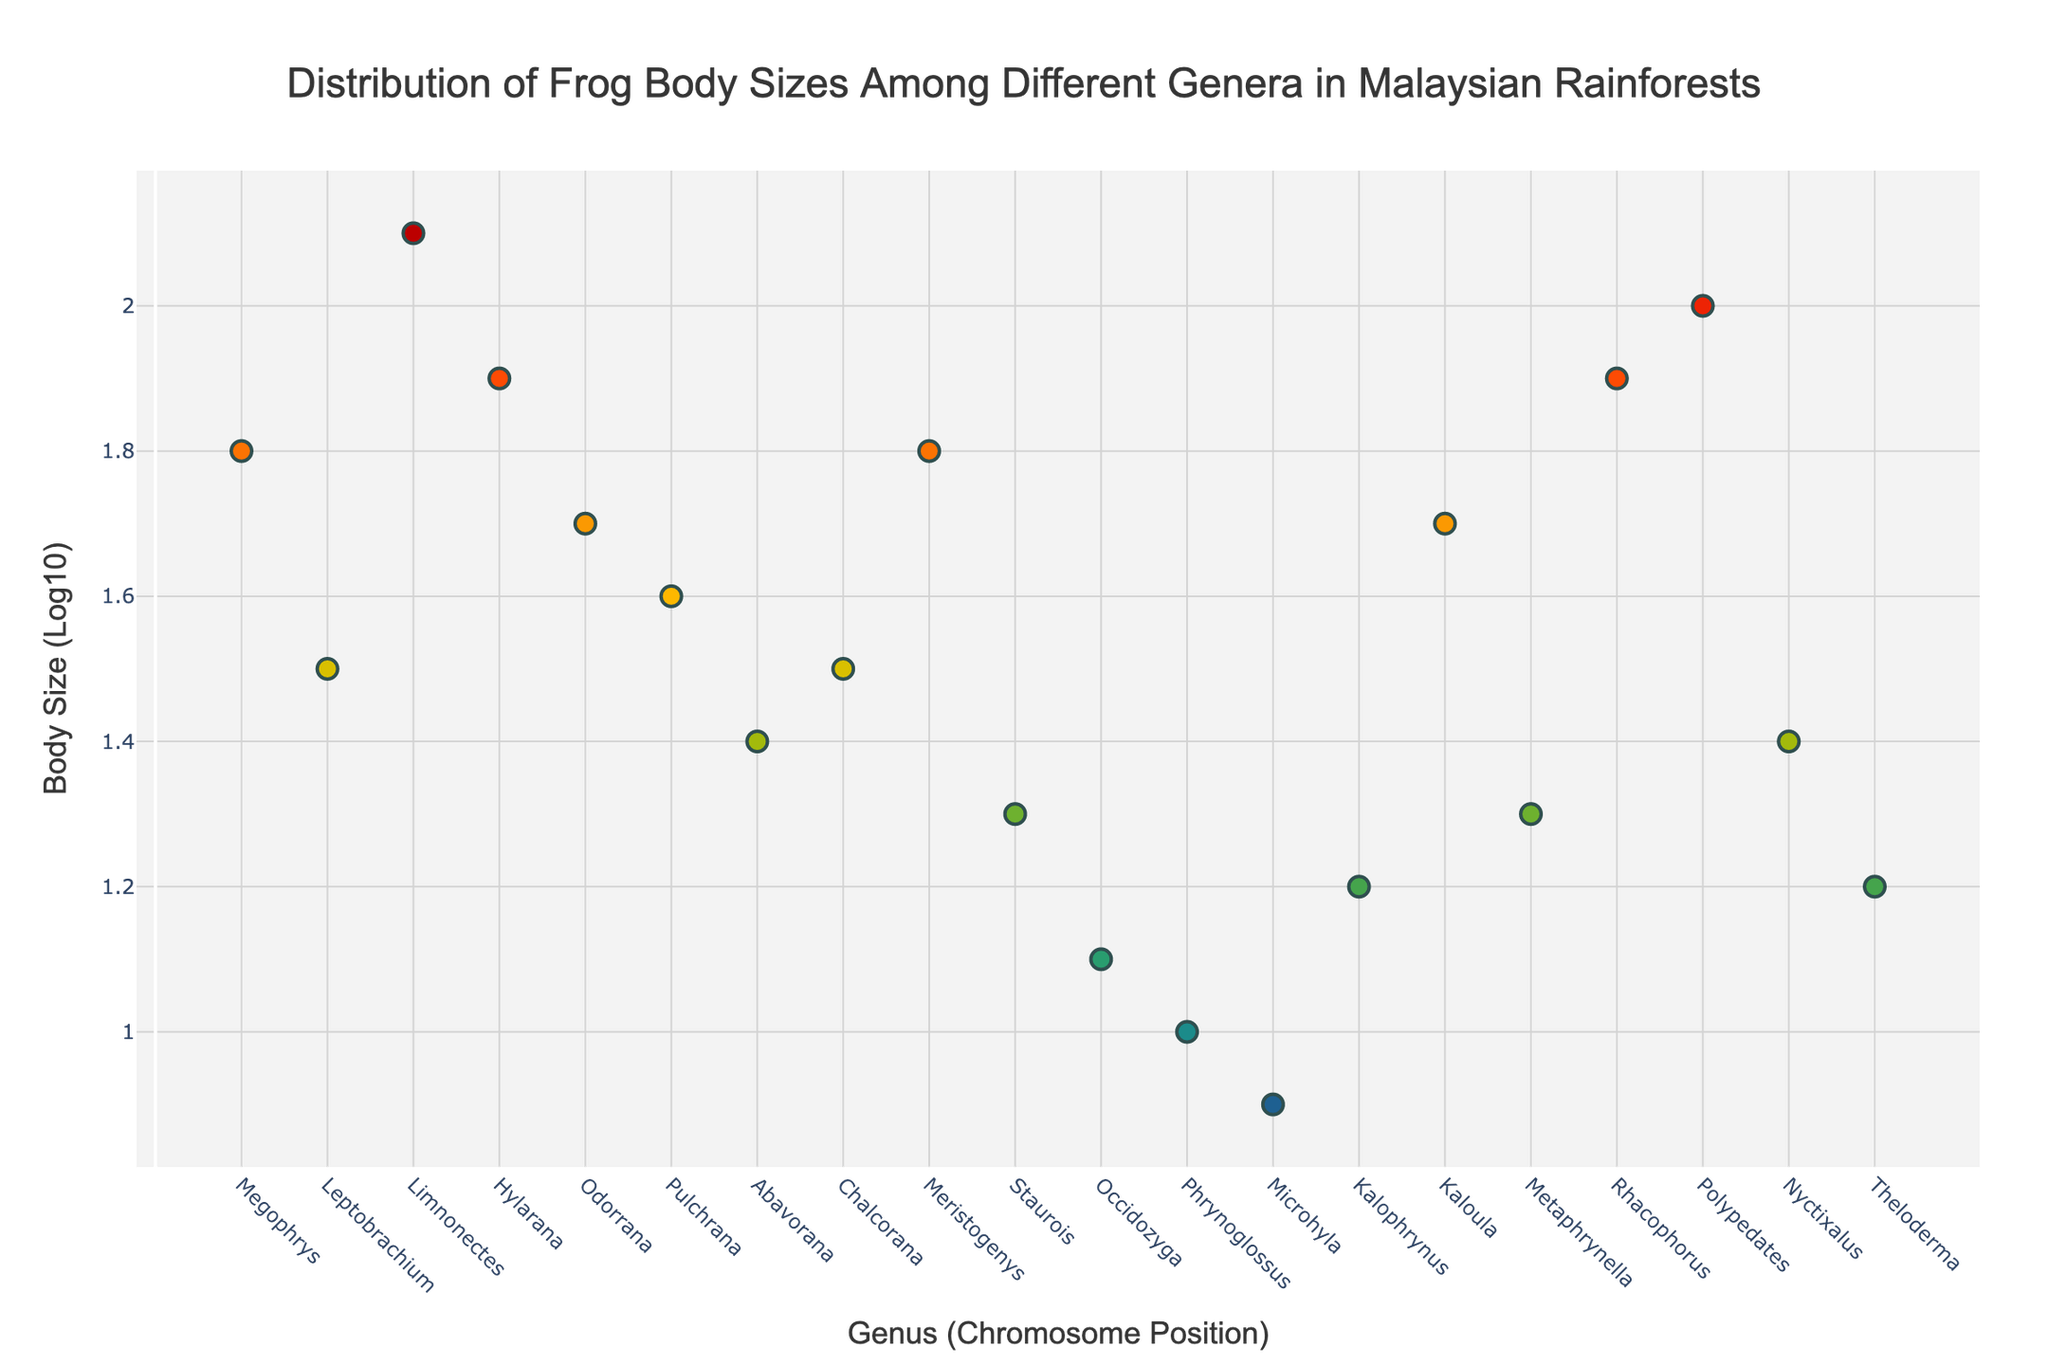what is the title of the plot? The title is displayed at the top of the plot. It states the main subject or message of the plot. In this case, it reads "Distribution of Frog Body Sizes Among Different Genera in Malaysian Rainforests."
Answer: Distribution of Frog Body Sizes Among Different Genera in Malaysian Rainforests How many genera are represented in the plot? To find the number of genera, count the number of unique markers on the x-axis, each corresponding to a different genus. In this plot, there are 20 such markers.
Answer: 20 Which genus has the largest average body size? Find the highest point on the y-axis and refer to the corresponding genus on the x-axis. Here, Limnonectes at chromosome position 3 has the highest body size of 2.1(log10).
Answer: Limnonectes What is the body size (log10) value for the genus Microhyla? Look for the marker corresponding to Microhyla on the x-axis and note the y-value associated with it, which is 0.9 (log10).
Answer: 0.9 Which genus has a body size closest to 1.5 (log10)? Identify the genotype whose body size is closest to 1.5 on the y-axis. Both Leptobrachium and Chalcorana have this value.
Answer: Leptobrachium and Chalcorana How many genera have a body size greater than 1.8 (log10)? Count the number of data points with a y-value greater than 1.8. They are Limnonectes, Hylarana, Polypedates, and Rhacophorus.
Answer: 4 Are there any genera with a body size less than 1.0 (log10)? Observe the markers on the y-axis to identify any points below 1. The genus Phrynoglossus has a body size of 1.0, and Microhyla has a body size of 0.9, but none are below 1.
Answer: No Which genera lie between the body sizes of 1.3 and 1.7 (log10)? Identify all markers with y-values between 1.3 and 1.7. These include Leptobrachium, Chalcorana, Pulchrana, Kaloula, Staurois, and Metaphrynella.
Answer: Leptobrachium, Chalcorana, Pulchrana, Kaloula, Staurois, Metaphrynella How many genera have a body size exactly equal to the median body size of all genera? First, find the median of all body sizes. Sorting the body sizes, the median (middle value) is 1.45. No genus has this exact body size.
Answer: None Is there a significant trend in body size across chromosome positions? Observe the general pattern of the data points along the x-axis and note if there is an upward or downward trend or if it appears random. The body sizes appear to stay within a certain range without a clear upward or downward trend across chromosome positions.
Answer: No significant trend 